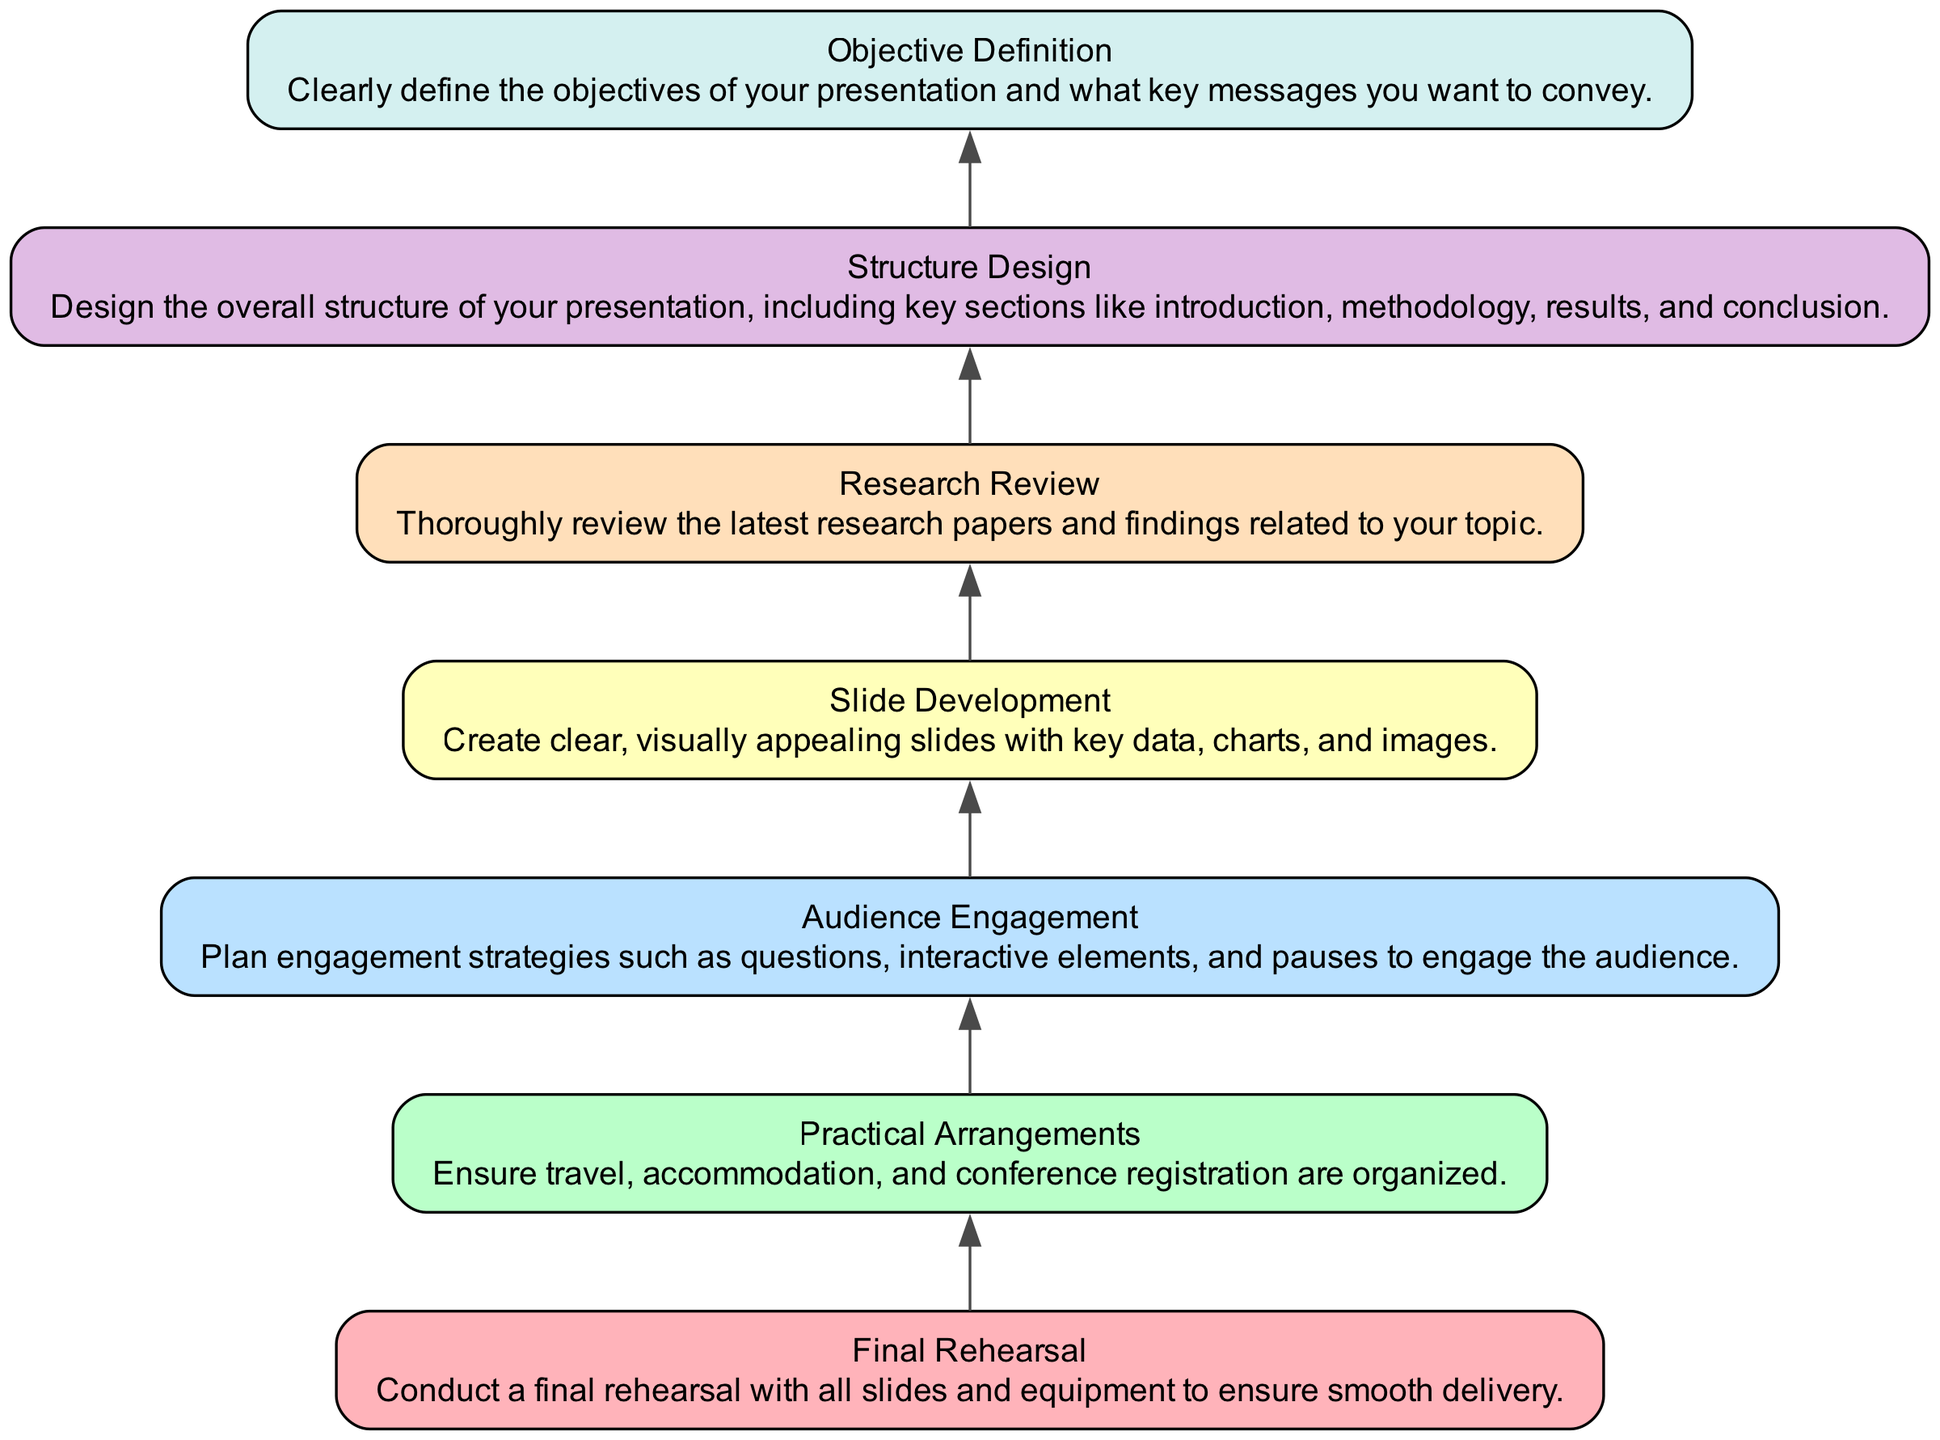What's the top node in the diagram? The top node in the diagram represents the final step in the preparation and is labeled "Final Rehearsal." It indicates the culmination of all the previous steps leading to the presentation.
Answer: Final Rehearsal How many nodes are there in total? By counting each unique element in the diagram from the bottom to the top, we identify that there are seven distinct nodes showcasing various steps in the presentation preparation.
Answer: Seven What step comes before "Slide Development"? The node labeled "Structure Design" is positioned directly below "Slide Development," indicating it is the preceding step in the flow of the diagram.
Answer: Structure Design Which node focuses on engaging the audience? The node titled "Audience Engagement" explicitly addresses strategies for interacting with the audience during the presentation.
Answer: Audience Engagement What is the objective defined in the diagram? The task of defining clear objectives for the presentation is represented by the "Objective Definition" node, which appears at the bottom of the flowchart.
Answer: Objective Definition How do "Research Review" and "Slide Development" relate? "Research Review" is positioned below "Slide Development," indicating that reviewing relevant research is a prerequisite step before creating the slides for the talk.
Answer: Research Review How many edges connect the nodes? The nodes are interconnected with six edges, each representing a direct relationship and the flow from one step to the next in preparing the presentation.
Answer: Six Which step is the first in the flowchart? The first step identified at the bottom of the diagram is "Objective Definition," indicating the starting point for the preparation process.
Answer: Objective Definition What is the main focus of the "Practical Arrangements" step? This step emphasizes organizing logistical elements such as travel, accommodation, and conference registration, ensuring they are in place before the actual conference.
Answer: Travel, accommodation, conference registration 